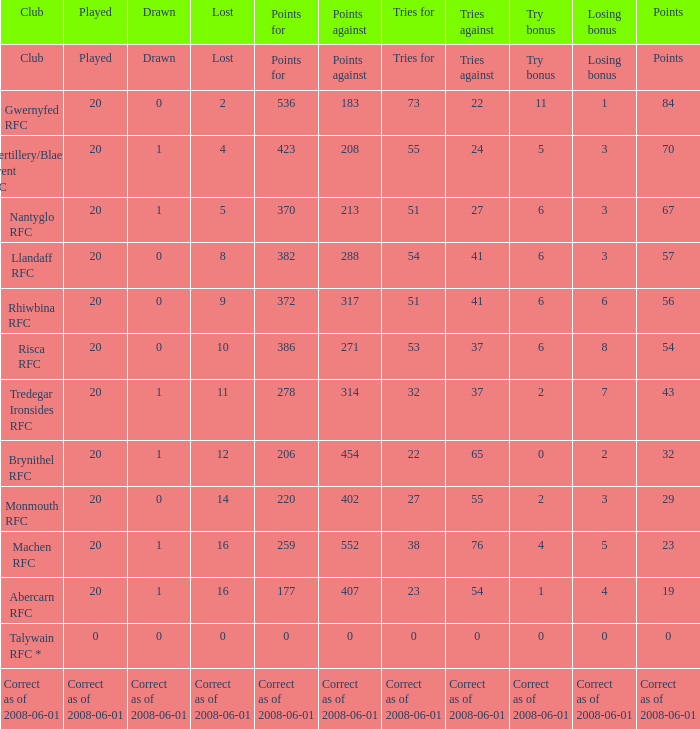What was the tries against when they had 32 tries for? 37.0. 